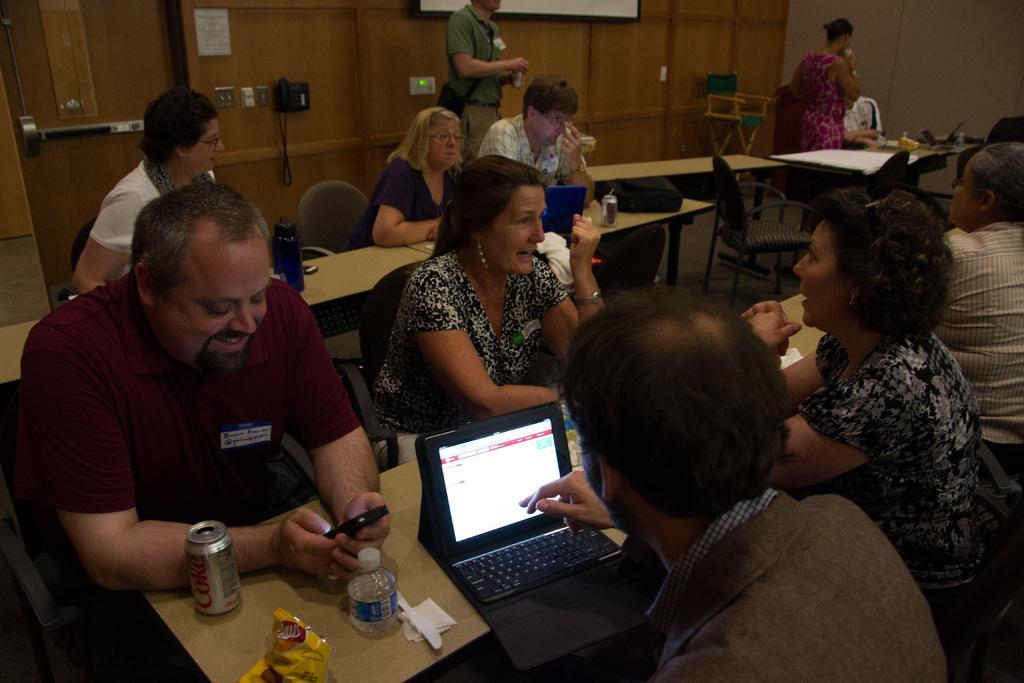How would you summarize this image in a sentence or two? In the picture we can see some people are sitting on the chairs near the table and we can also see a laptop, bottle, coke tin, on the table, and one man is using mobile phone and smiling in the background we can see there is a wall, to the wall there is a telephone, and a man standing and opening a tin and to right hand side there is a chair and one woman standing. 